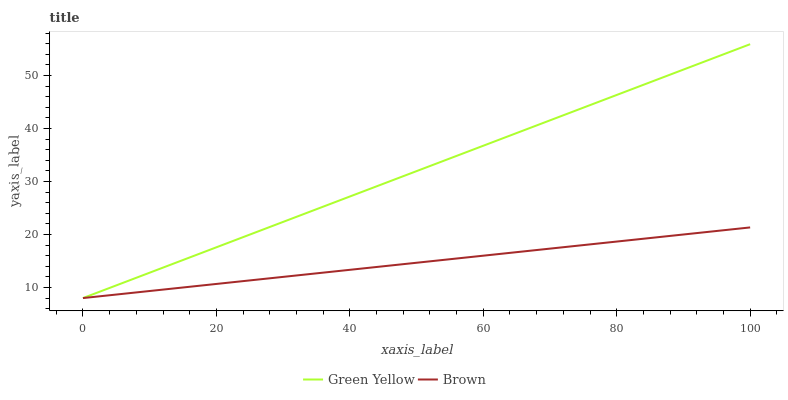Does Brown have the minimum area under the curve?
Answer yes or no. Yes. Does Green Yellow have the maximum area under the curve?
Answer yes or no. Yes. Does Green Yellow have the minimum area under the curve?
Answer yes or no. No. Is Brown the smoothest?
Answer yes or no. Yes. Is Green Yellow the roughest?
Answer yes or no. Yes. Is Green Yellow the smoothest?
Answer yes or no. No. Does Brown have the lowest value?
Answer yes or no. Yes. Does Green Yellow have the highest value?
Answer yes or no. Yes. Does Green Yellow intersect Brown?
Answer yes or no. Yes. Is Green Yellow less than Brown?
Answer yes or no. No. Is Green Yellow greater than Brown?
Answer yes or no. No. 